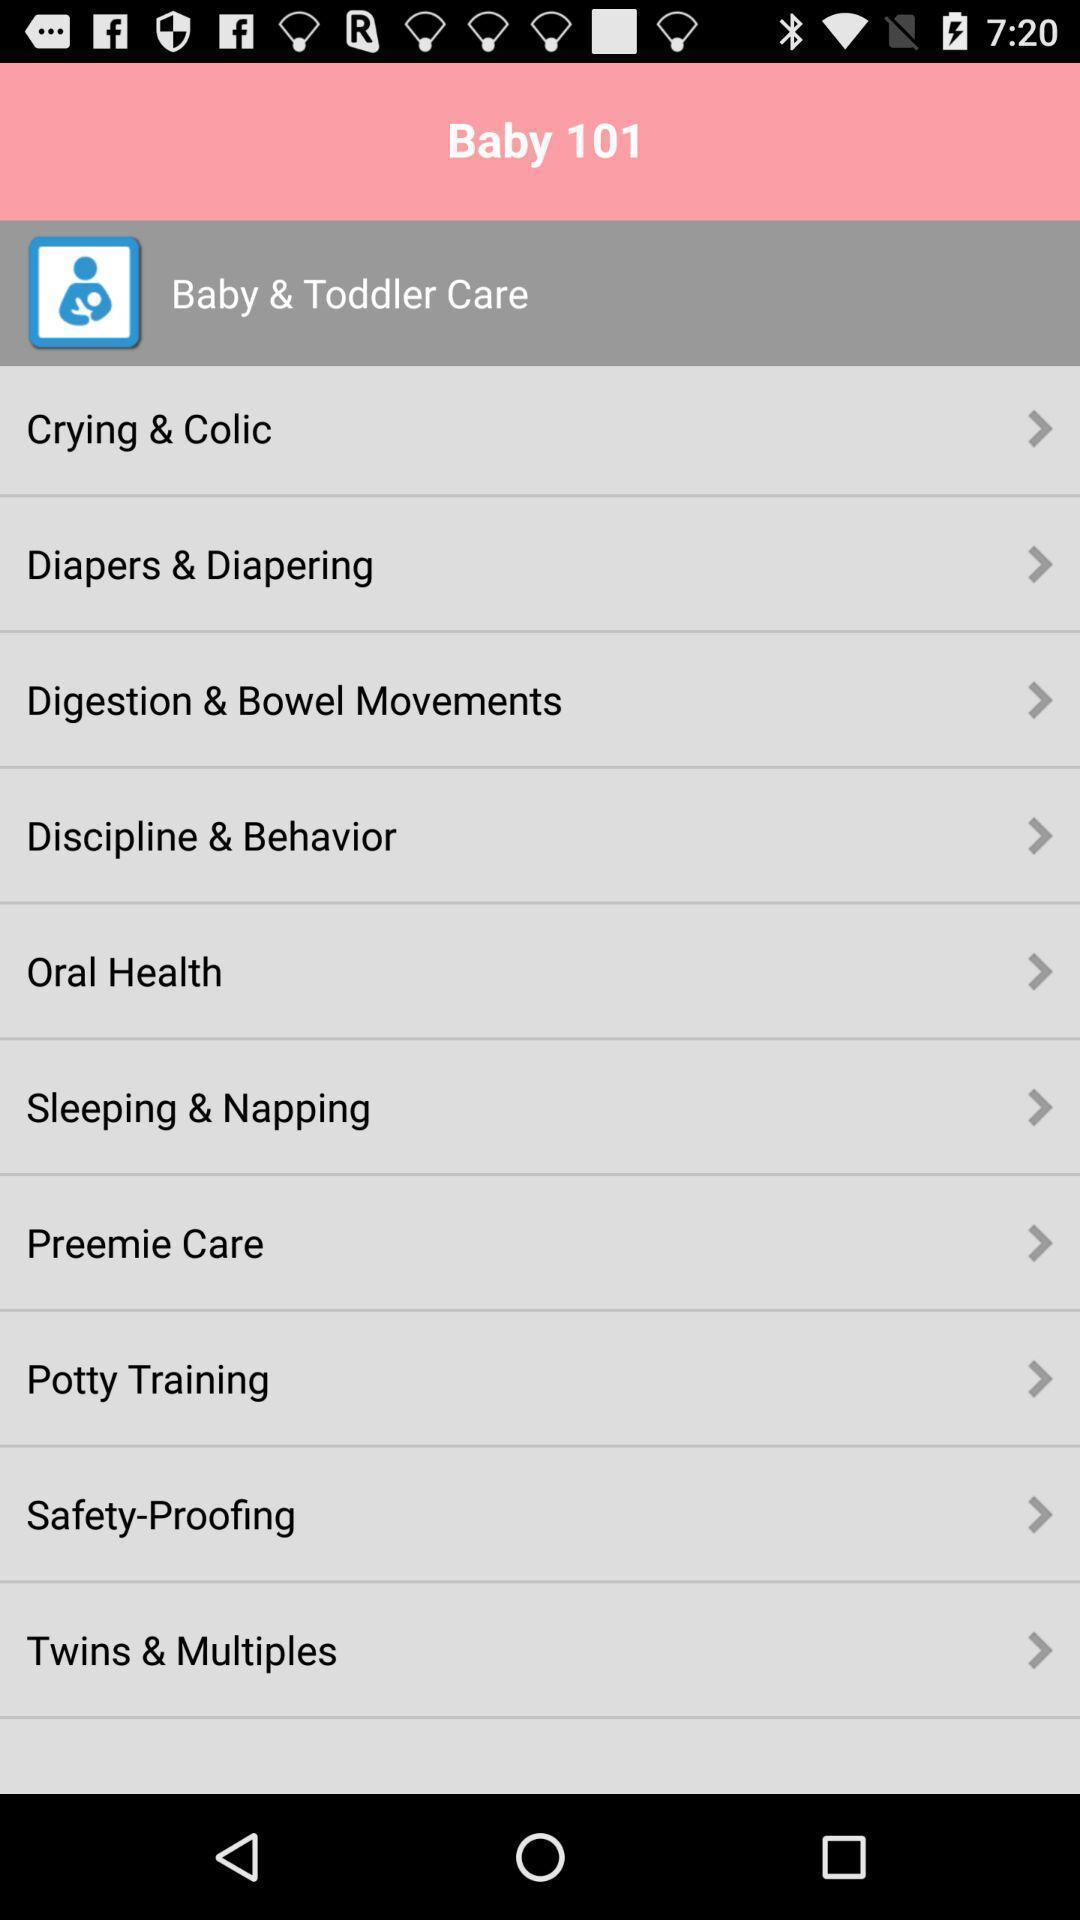What details can you identify in this image? Screen shows multiple options in baby app. 